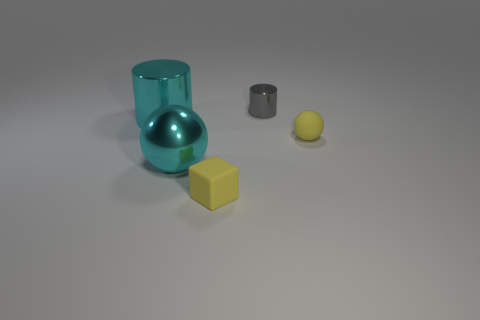Add 1 tiny yellow cubes. How many objects exist? 6 Subtract 1 cylinders. How many cylinders are left? 1 Subtract all balls. How many objects are left? 3 Subtract all cyan spheres. How many spheres are left? 1 Subtract all gray spheres. Subtract all blue cylinders. How many spheres are left? 2 Subtract all red blocks. How many yellow balls are left? 1 Subtract all tiny spheres. Subtract all rubber cubes. How many objects are left? 3 Add 4 metal cylinders. How many metal cylinders are left? 6 Add 1 yellow matte spheres. How many yellow matte spheres exist? 2 Subtract 0 gray spheres. How many objects are left? 5 